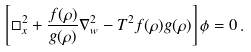Convert formula to latex. <formula><loc_0><loc_0><loc_500><loc_500>\left [ \Box _ { x } ^ { 2 } + \frac { f ( \rho ) } { g ( \rho ) } \nabla _ { w } ^ { 2 } - T ^ { 2 } f ( \rho ) g ( \rho ) \right ] \phi = 0 \, .</formula> 